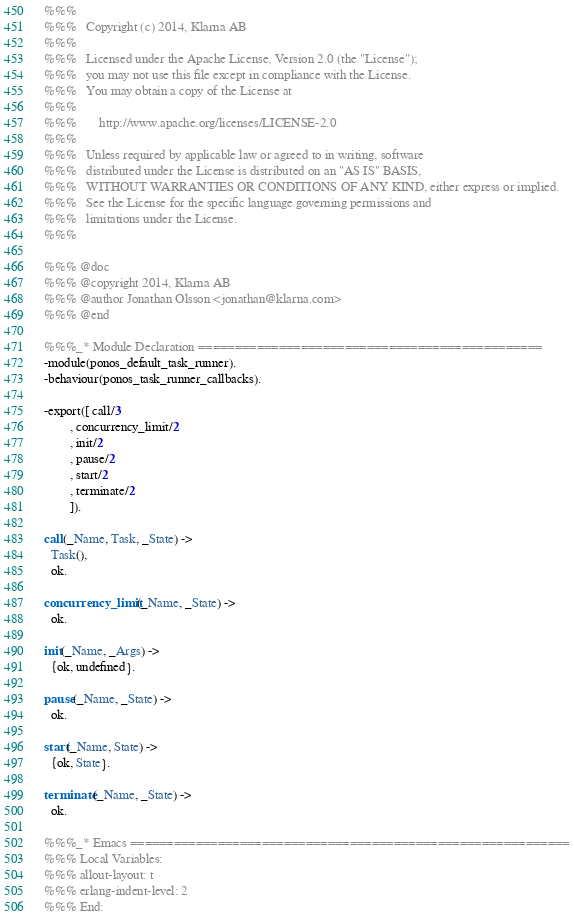Convert code to text. <code><loc_0><loc_0><loc_500><loc_500><_Erlang_>%%%
%%%   Copyright (c) 2014, Klarna AB
%%%
%%%   Licensed under the Apache License, Version 2.0 (the "License");
%%%   you may not use this file except in compliance with the License.
%%%   You may obtain a copy of the License at
%%%
%%%       http://www.apache.org/licenses/LICENSE-2.0
%%%
%%%   Unless required by applicable law or agreed to in writing, software
%%%   distributed under the License is distributed on an "AS IS" BASIS,
%%%   WITHOUT WARRANTIES OR CONDITIONS OF ANY KIND, either express or implied.
%%%   See the License for the specific language governing permissions and
%%%   limitations under the License.
%%%

%%% @doc
%%% @copyright 2014, Klarna AB
%%% @author Jonathan Olsson <jonathan@klarna.com>
%%% @end

%%%_* Module Declaration ===============================================
-module(ponos_default_task_runner).
-behaviour(ponos_task_runner_callbacks).

-export([ call/3
        , concurrency_limit/2
        , init/2
        , pause/2
        , start/2
        , terminate/2
        ]).

call(_Name, Task, _State) ->
  Task(),
  ok.

concurrency_limit(_Name, _State) ->
  ok.

init(_Name, _Args) ->
  {ok, undefined}.

pause(_Name, _State) ->
  ok.

start(_Name, State) ->
  {ok, State}.

terminate(_Name, _State) ->
  ok.

%%%_* Emacs ============================================================
%%% Local Variables:
%%% allout-layout: t
%%% erlang-indent-level: 2
%%% End:
</code> 